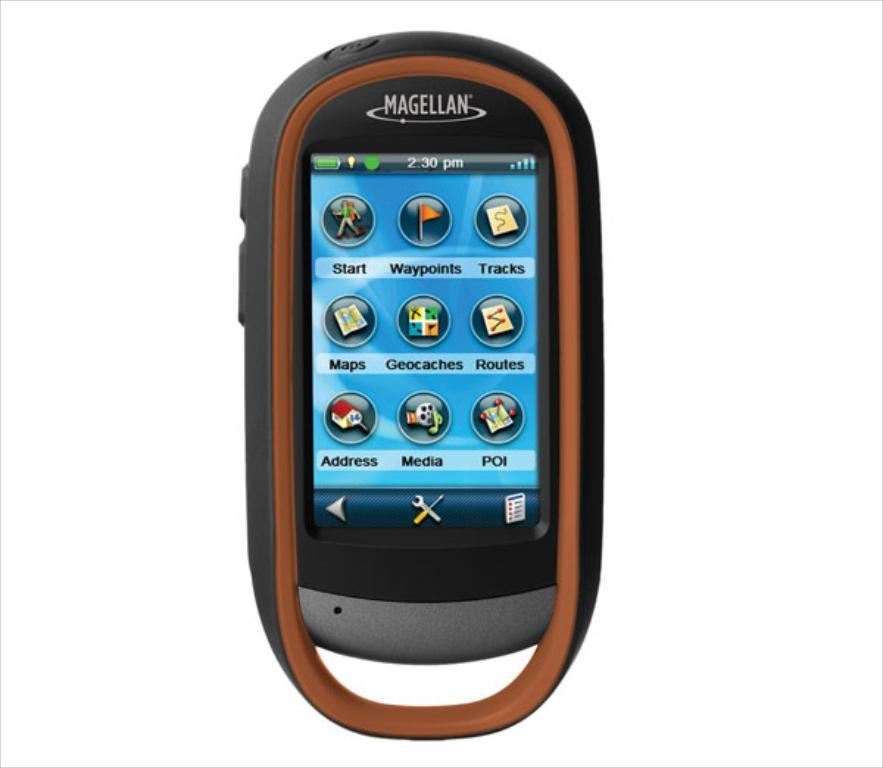What is the main subject in the image? There is a mobile in the image. What type of pear is hanging from the stem in the image? There is no pear or stem present in the image; it only features a mobile. 